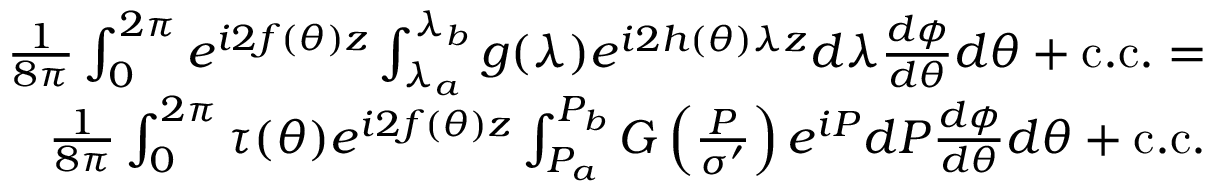<formula> <loc_0><loc_0><loc_500><loc_500>\begin{array} { r } { \frac { 1 } { 8 \pi } \int _ { 0 } ^ { 2 \pi } e ^ { i 2 f ( \theta ) z } \int _ { \lambda _ { a } } ^ { \lambda _ { b } } g ( \lambda ) e ^ { i 2 h ( \theta ) \lambda z } d \lambda \frac { d \phi } { d \theta } d \theta + c . c . = } \\ { \frac { 1 } { 8 \pi } \int _ { 0 } ^ { 2 \pi } \tau ( \theta ) e ^ { i 2 f ( \theta ) z } \int _ { P _ { a } } ^ { P _ { b } } G \left ( \frac { P } { \sigma ^ { \prime } } \right ) e ^ { i P } d P \frac { d \phi } { d \theta } d \theta + c . c . } \end{array}</formula> 